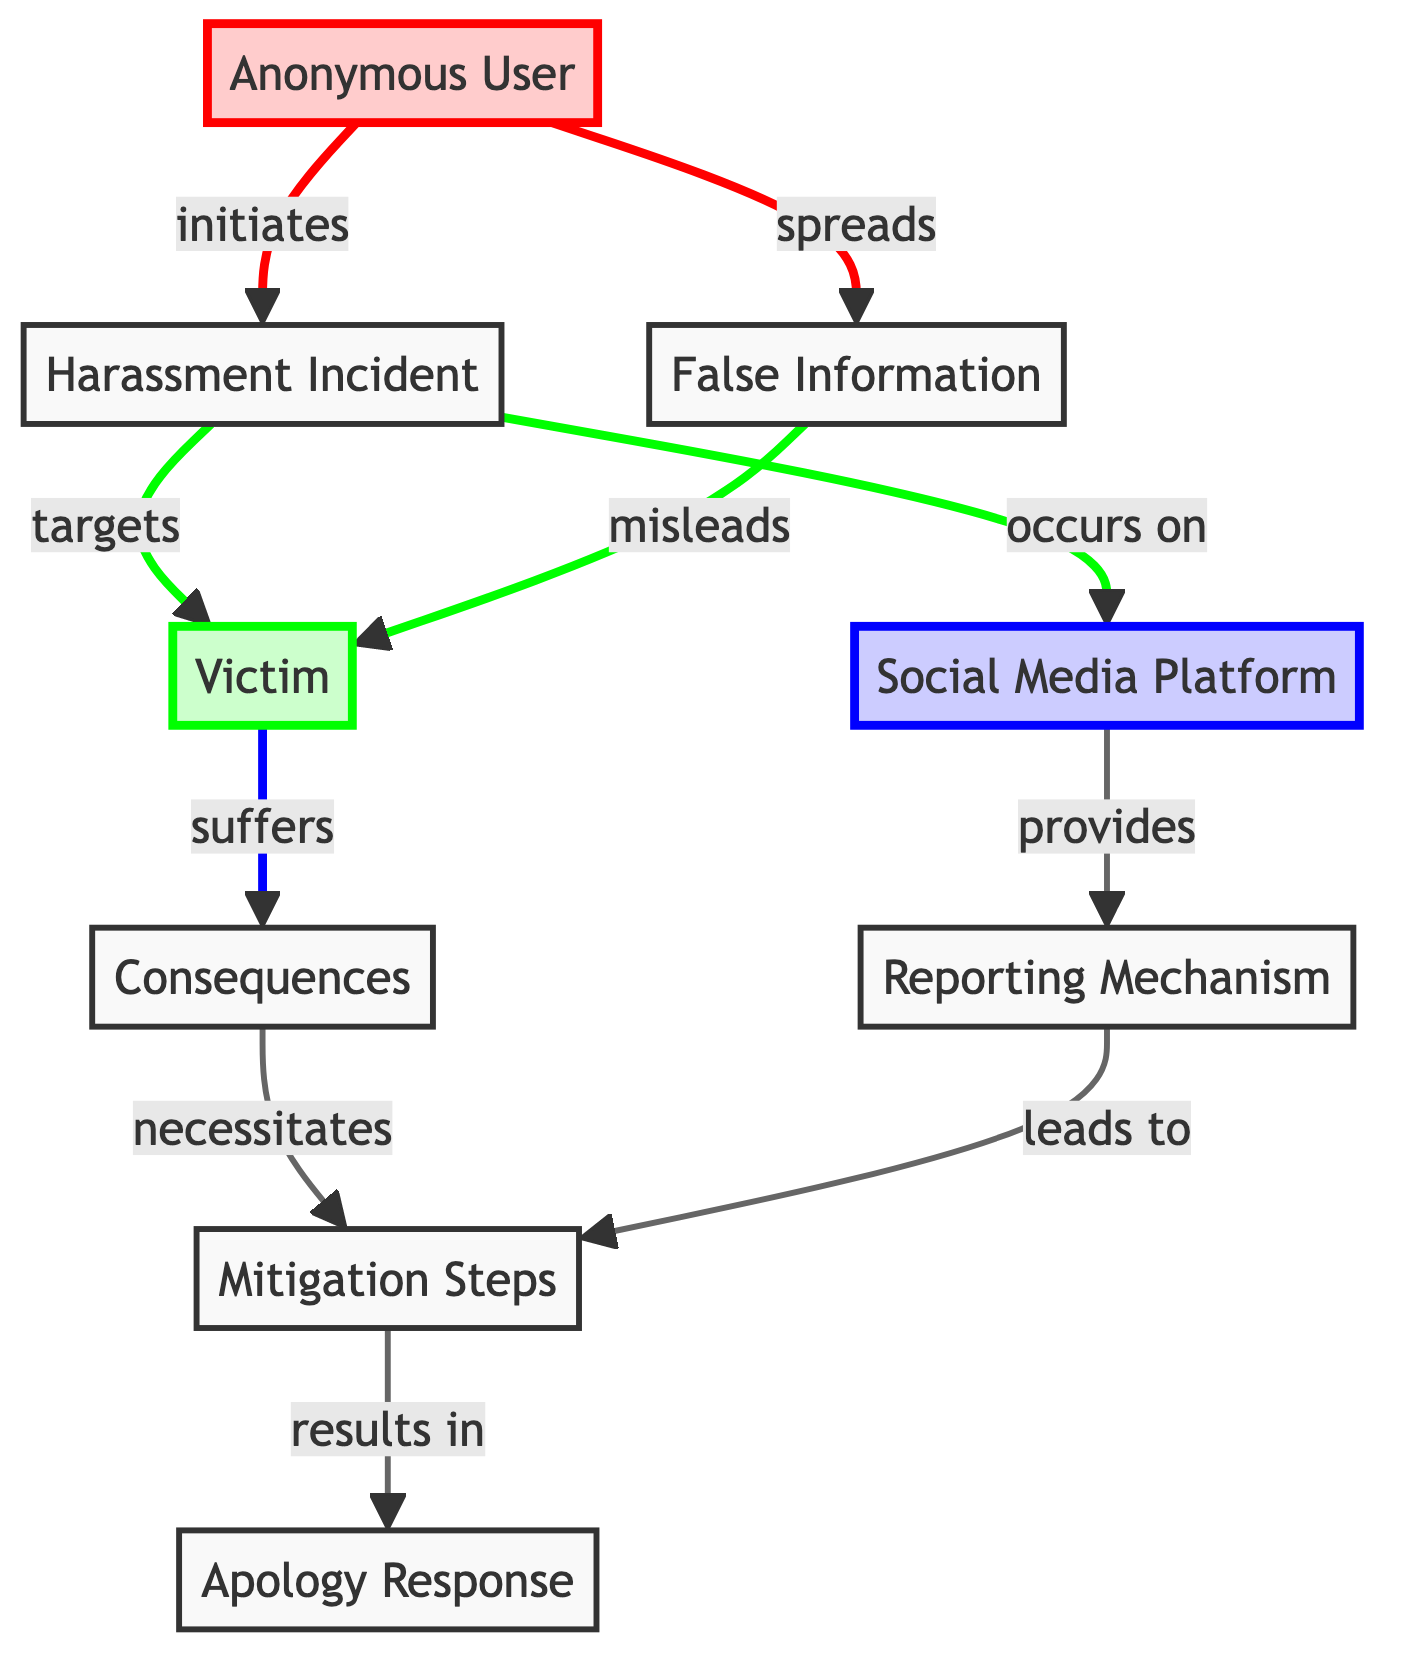What is the first node in the diagram? The first node in the diagram is labeled "Harassment Incident", which is represented at the top of the flow.
Answer: Harassment Incident How many nodes are present in the diagram? By counting all distinct labeled nodes, there are a total of nine nodes in the diagram.
Answer: Nine Which node does the "Anonymous User" initiate? The "Anonymous User" initiates the "Harassment Incident", as indicated by the arrow pointing from the "Anonymous User" to the "Harassment Incident".
Answer: Harassment Incident What is the consequence suffered by the victim? The victim suffers "Consequences", which is indicated as the direct outcome of the "Harassment Incident".
Answer: Consequences What does the "Social Media Platform" provide? The "Social Media Platform" provides a "Reporting Mechanism", as shown by the link leading from the "Social Media Platform" to the "Reporting Mechanism".
Answer: Reporting Mechanism What action occurs as a result of the "Reporting Mechanism"? The action that occurs as a result of the "Reporting Mechanism" leads to "Mitigation Steps", which are displayed as the next node in the flow.
Answer: Mitigation Steps Which node is the last step in the cycle represented in the diagram? The last step in the cycle is the "Apology Response", which is the end node after following through the "Mitigation Steps".
Answer: Apology Response What node does the "Victim" suffer consequences from? The "Victim" suffers consequences from the "Harassment Incident", which indicates that they are directly targeted by this incident.
Answer: Harassment Incident Which relationship leads to an apology response? The relationship that leads to the "Apology Response" is from the "Mitigation Steps", as it indicates a resolution process following the reported incident.
Answer: Mitigation Steps 